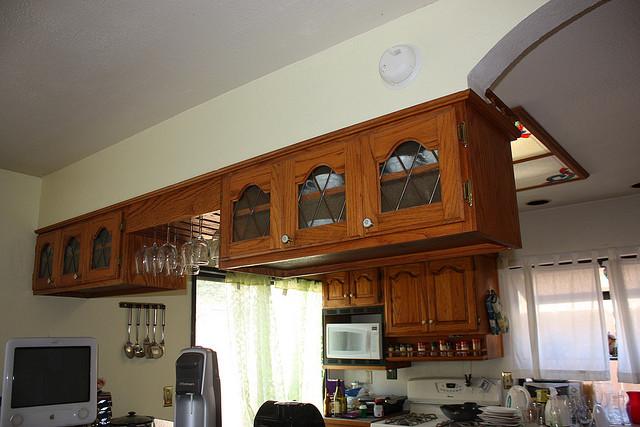What color are the cabinets?
Answer briefly. Brown. Where are the glasses?
Be succinct. Hanging. Is this a commercial kitchen?
Concise answer only. No. Is this a clean house?
Quick response, please. Yes. What is in the kitchen?
Concise answer only. Dishes. Is the room lit?
Be succinct. Yes. What color is the microwave?
Quick response, please. White. Are there lights?
Give a very brief answer. No. Where are the cooking utensils, like spatulas and spoons, kept?
Be succinct. Drawer. Is it dim here?
Quick response, please. No. Is the building residential or commercial?
Be succinct. Residential. 